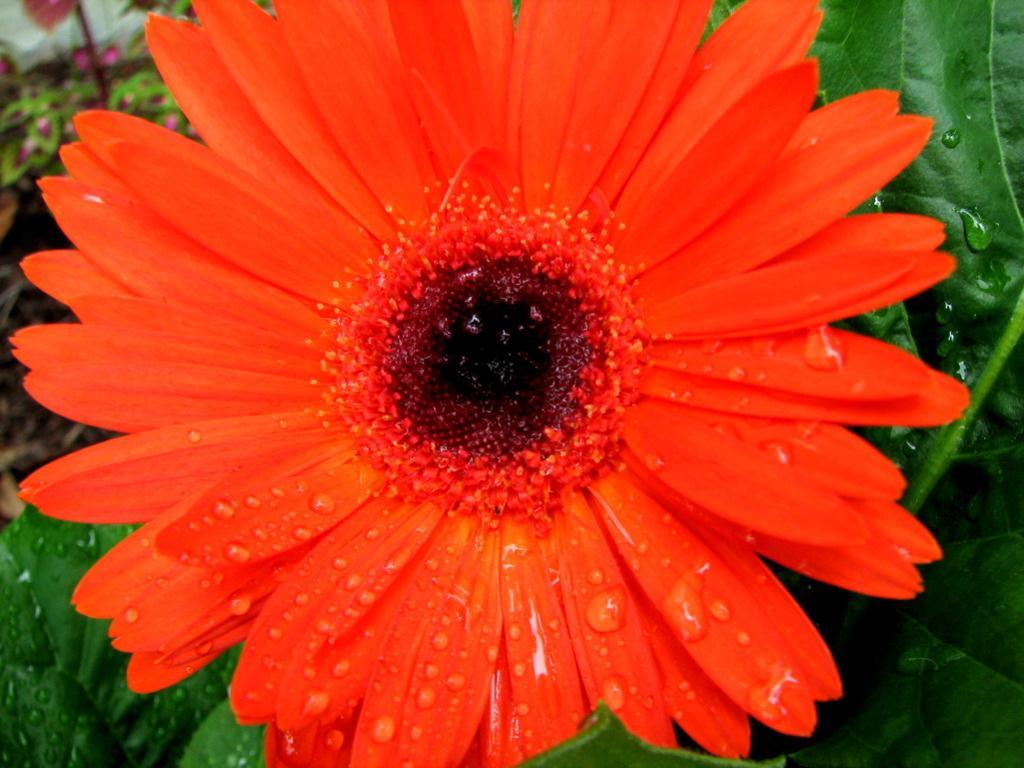How would you summarize this image in a sentence or two? This is red color sunflower. These are leaves. 